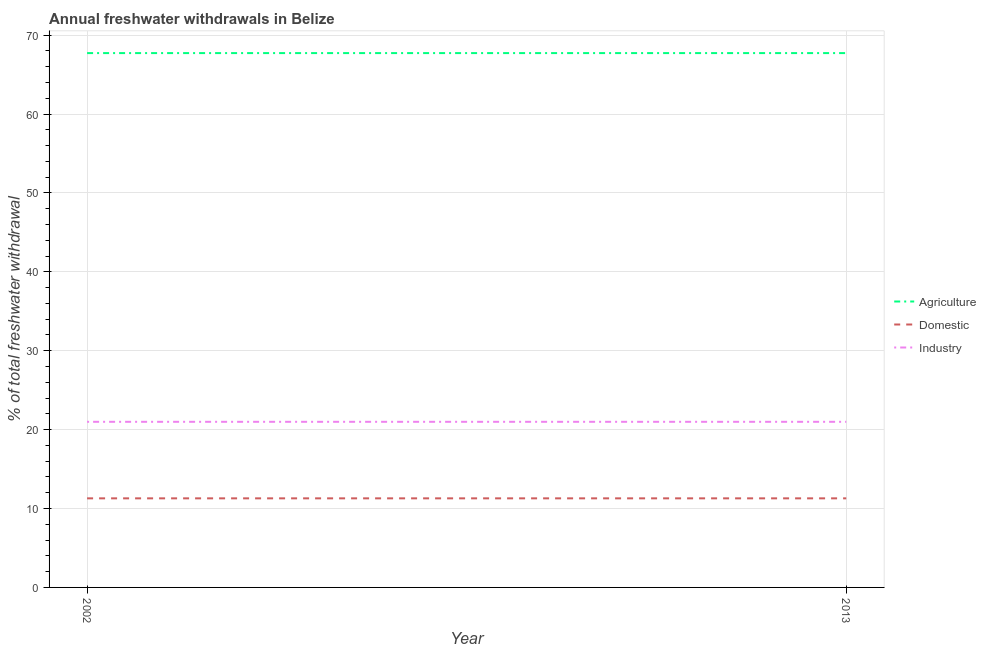How many different coloured lines are there?
Give a very brief answer. 3. Is the number of lines equal to the number of legend labels?
Give a very brief answer. Yes. What is the percentage of freshwater withdrawal for agriculture in 2002?
Offer a terse response. 67.72. Across all years, what is the maximum percentage of freshwater withdrawal for agriculture?
Provide a short and direct response. 67.72. Across all years, what is the minimum percentage of freshwater withdrawal for industry?
Your answer should be compact. 20.99. In which year was the percentage of freshwater withdrawal for agriculture maximum?
Ensure brevity in your answer.  2002. In which year was the percentage of freshwater withdrawal for agriculture minimum?
Give a very brief answer. 2002. What is the total percentage of freshwater withdrawal for agriculture in the graph?
Your answer should be compact. 135.44. What is the difference between the percentage of freshwater withdrawal for domestic purposes in 2013 and the percentage of freshwater withdrawal for industry in 2002?
Your answer should be very brief. -9.7. What is the average percentage of freshwater withdrawal for industry per year?
Offer a terse response. 20.99. In the year 2013, what is the difference between the percentage of freshwater withdrawal for domestic purposes and percentage of freshwater withdrawal for industry?
Your answer should be very brief. -9.7. Is it the case that in every year, the sum of the percentage of freshwater withdrawal for agriculture and percentage of freshwater withdrawal for domestic purposes is greater than the percentage of freshwater withdrawal for industry?
Make the answer very short. Yes. Does the percentage of freshwater withdrawal for industry monotonically increase over the years?
Your answer should be very brief. No. How many lines are there?
Provide a short and direct response. 3. Does the graph contain grids?
Offer a terse response. Yes. Where does the legend appear in the graph?
Ensure brevity in your answer.  Center right. What is the title of the graph?
Your answer should be compact. Annual freshwater withdrawals in Belize. Does "Social Protection" appear as one of the legend labels in the graph?
Your answer should be very brief. No. What is the label or title of the Y-axis?
Offer a terse response. % of total freshwater withdrawal. What is the % of total freshwater withdrawal in Agriculture in 2002?
Your answer should be compact. 67.72. What is the % of total freshwater withdrawal of Domestic in 2002?
Make the answer very short. 11.29. What is the % of total freshwater withdrawal in Industry in 2002?
Your response must be concise. 20.99. What is the % of total freshwater withdrawal in Agriculture in 2013?
Offer a terse response. 67.72. What is the % of total freshwater withdrawal of Domestic in 2013?
Keep it short and to the point. 11.29. What is the % of total freshwater withdrawal of Industry in 2013?
Your answer should be very brief. 20.99. Across all years, what is the maximum % of total freshwater withdrawal in Agriculture?
Provide a short and direct response. 67.72. Across all years, what is the maximum % of total freshwater withdrawal in Domestic?
Ensure brevity in your answer.  11.29. Across all years, what is the maximum % of total freshwater withdrawal of Industry?
Your answer should be very brief. 20.99. Across all years, what is the minimum % of total freshwater withdrawal in Agriculture?
Your response must be concise. 67.72. Across all years, what is the minimum % of total freshwater withdrawal of Domestic?
Your answer should be compact. 11.29. Across all years, what is the minimum % of total freshwater withdrawal of Industry?
Your answer should be very brief. 20.99. What is the total % of total freshwater withdrawal of Agriculture in the graph?
Your answer should be very brief. 135.44. What is the total % of total freshwater withdrawal of Domestic in the graph?
Offer a very short reply. 22.58. What is the total % of total freshwater withdrawal in Industry in the graph?
Offer a very short reply. 41.98. What is the difference between the % of total freshwater withdrawal of Agriculture in 2002 and that in 2013?
Your answer should be compact. 0. What is the difference between the % of total freshwater withdrawal of Agriculture in 2002 and the % of total freshwater withdrawal of Domestic in 2013?
Your answer should be compact. 56.43. What is the difference between the % of total freshwater withdrawal of Agriculture in 2002 and the % of total freshwater withdrawal of Industry in 2013?
Offer a terse response. 46.73. What is the difference between the % of total freshwater withdrawal in Domestic in 2002 and the % of total freshwater withdrawal in Industry in 2013?
Provide a succinct answer. -9.7. What is the average % of total freshwater withdrawal in Agriculture per year?
Offer a very short reply. 67.72. What is the average % of total freshwater withdrawal of Domestic per year?
Give a very brief answer. 11.29. What is the average % of total freshwater withdrawal of Industry per year?
Keep it short and to the point. 20.99. In the year 2002, what is the difference between the % of total freshwater withdrawal of Agriculture and % of total freshwater withdrawal of Domestic?
Give a very brief answer. 56.43. In the year 2002, what is the difference between the % of total freshwater withdrawal in Agriculture and % of total freshwater withdrawal in Industry?
Offer a terse response. 46.73. In the year 2013, what is the difference between the % of total freshwater withdrawal in Agriculture and % of total freshwater withdrawal in Domestic?
Your answer should be compact. 56.43. In the year 2013, what is the difference between the % of total freshwater withdrawal in Agriculture and % of total freshwater withdrawal in Industry?
Your answer should be compact. 46.73. What is the ratio of the % of total freshwater withdrawal in Domestic in 2002 to that in 2013?
Your answer should be very brief. 1. What is the difference between the highest and the second highest % of total freshwater withdrawal in Agriculture?
Offer a terse response. 0. What is the difference between the highest and the second highest % of total freshwater withdrawal in Domestic?
Your answer should be very brief. 0. What is the difference between the highest and the second highest % of total freshwater withdrawal of Industry?
Provide a succinct answer. 0. What is the difference between the highest and the lowest % of total freshwater withdrawal in Industry?
Give a very brief answer. 0. 